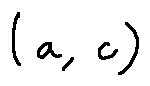Convert formula to latex. <formula><loc_0><loc_0><loc_500><loc_500>( a , c )</formula> 